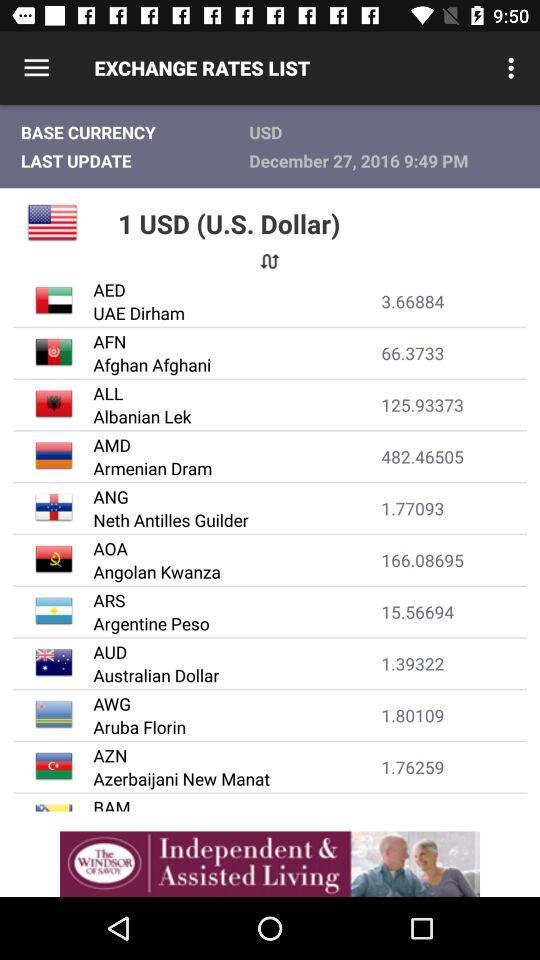When was it last updated? It was last updated on December 27, 2016 at 9:49 PM. 